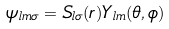<formula> <loc_0><loc_0><loc_500><loc_500>\psi _ { l m \sigma } = S _ { l \sigma } ( r ) Y _ { l m } ( \theta , \phi )</formula> 